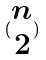<formula> <loc_0><loc_0><loc_500><loc_500>( \begin{matrix} n \\ 2 \end{matrix} )</formula> 